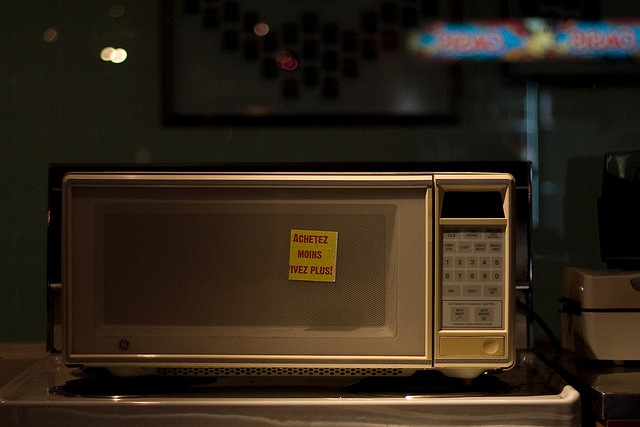Describe the objects in this image and their specific colors. I can see a microwave in black, maroon, and olive tones in this image. 